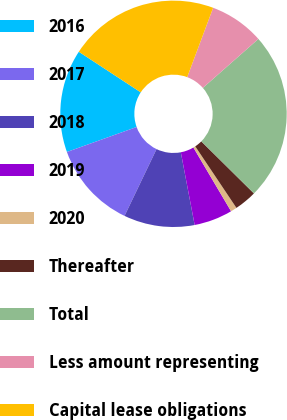Convert chart. <chart><loc_0><loc_0><loc_500><loc_500><pie_chart><fcel>2016<fcel>2017<fcel>2018<fcel>2019<fcel>2020<fcel>Thereafter<fcel>Total<fcel>Less amount representing<fcel>Capital lease obligations<nl><fcel>14.71%<fcel>12.41%<fcel>10.11%<fcel>5.5%<fcel>0.89%<fcel>3.2%<fcel>23.92%<fcel>7.8%<fcel>21.46%<nl></chart> 